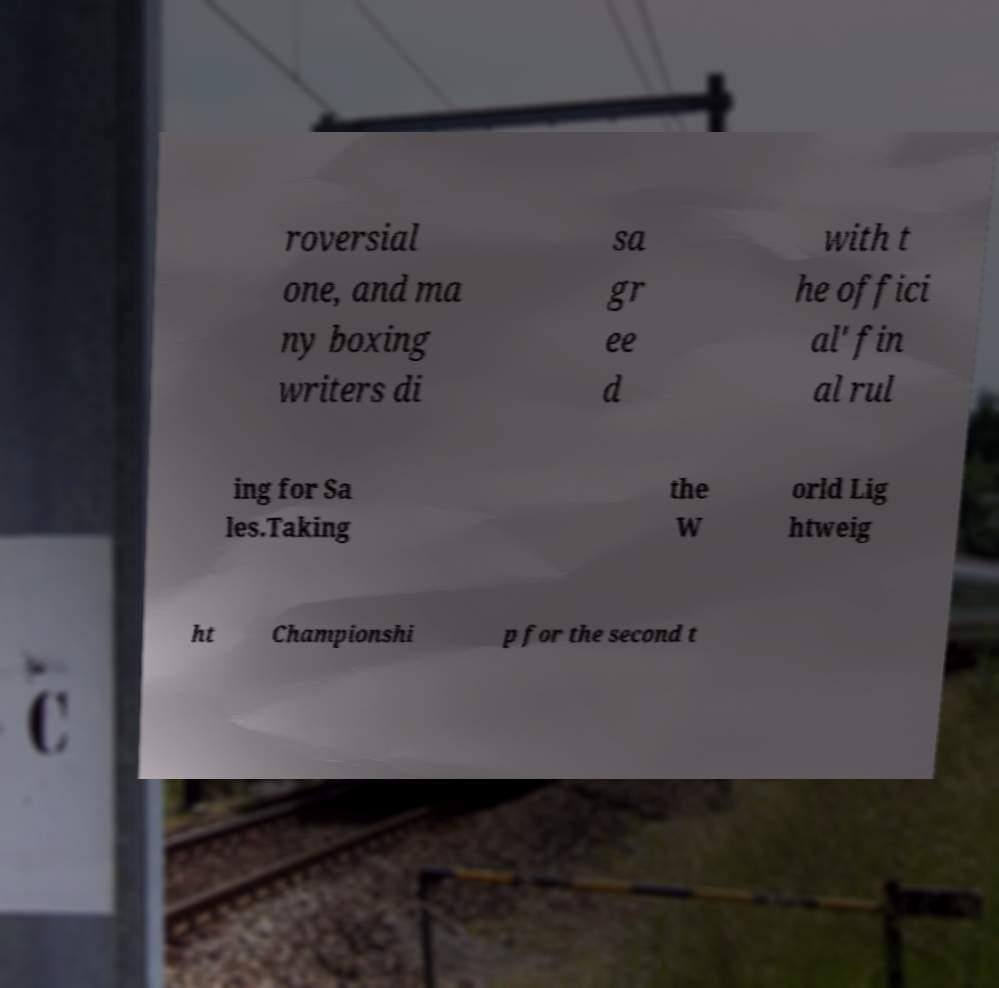I need the written content from this picture converted into text. Can you do that? roversial one, and ma ny boxing writers di sa gr ee d with t he offici al' fin al rul ing for Sa les.Taking the W orld Lig htweig ht Championshi p for the second t 